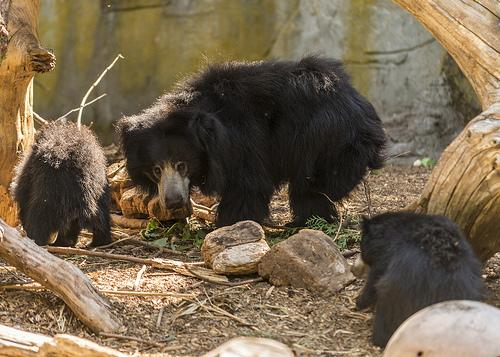Give a brief description of the waterscape in the image. The image contains calm, murky bodies of water in different sizes, located primarily at the top-right corner. Describe the composition of the image in terms of the arrangement of its elements. Bears are centered, with bodies of water at the top-right, rocks and twigs scattered around, and sunlight near the bottom. Describe the various natural elements present in the image. There are rocks, twigs, branches, sunlight, and green leaves in the image, scattered around the bears and bodies of water. Mention any notable details about the appearance of the black bears. One black bear has a large face, and another has a tiny head. They are located near the center-right of the image. Provide information about the parts of the bears that are visible in the image. Heads, legs, and eyes of bears are visible, as well as the back side of a bear and the back of a baby bear. Comment on the presence and appearance of sunlight and how it affects the scene. A patch of sunlight on the ground brightens the image and creates a natural, outdoorsy atmosphere, located at the center-bottom. Highlight the presence and location of the twig and branches. Large twigs are visible near the center-bottom, small pile of thin twigs is at the bottom, and a tree branch without leaves is on the left. Identify the primary objects and their locations in the image. Bears in the center, black bears on the left, rocks in the middle, and bodies of water at the top-right corner. Provide a brief overview of the scene captured in the image. The image features bears and black bears outdoors, surrounded by rocks, and near calm, murky bodies of water. Comment on the position and features of the legs of the bears. Bear legs are spread out throughout the image, with various sizes and positions, located mainly at the bottom. 